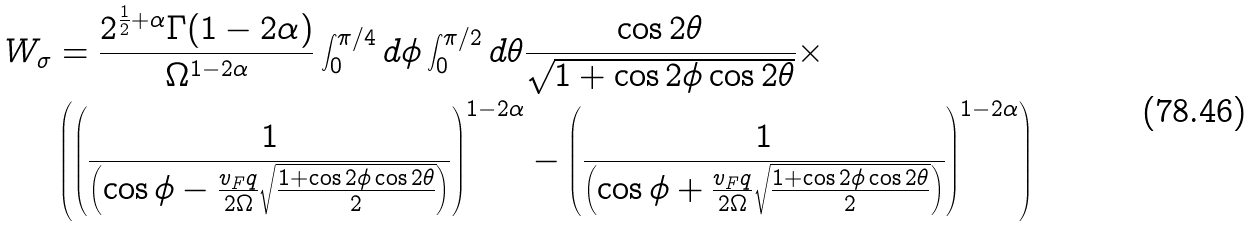Convert formula to latex. <formula><loc_0><loc_0><loc_500><loc_500>W _ { \sigma } & = \frac { 2 ^ { \frac { 1 } { 2 } + \alpha } \Gamma ( 1 - 2 \alpha ) } { \Omega ^ { 1 - 2 \alpha } } \int _ { 0 } ^ { \pi / 4 } d \phi \int _ { 0 } ^ { \pi / 2 } d \theta \frac { \cos 2 \theta } { \sqrt { 1 + \cos 2 \phi \cos 2 \theta } } \times \\ & \left ( \left ( \frac { 1 } { \left ( \cos \phi - \frac { v _ { F } q } { 2 \Omega } \sqrt { \frac { 1 + \cos 2 \phi \cos 2 \theta } { 2 } } \right ) } \right ) ^ { 1 - 2 \alpha } - \left ( \frac { 1 } { \left ( \cos \phi + \frac { v _ { F } q } { 2 \Omega } \sqrt { \frac { 1 + \cos 2 \phi \cos 2 \theta } { 2 } } \right ) } \right ) ^ { 1 - 2 \alpha } \right )</formula> 